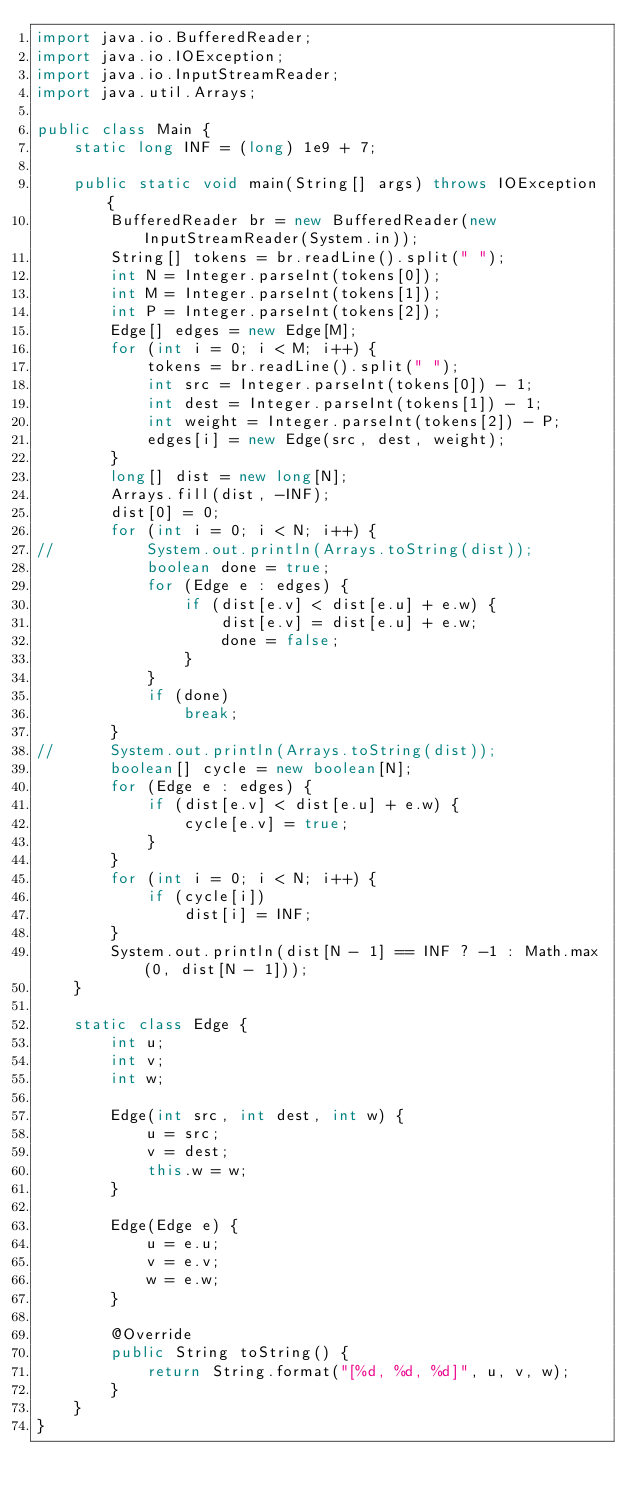<code> <loc_0><loc_0><loc_500><loc_500><_Java_>import java.io.BufferedReader;
import java.io.IOException;
import java.io.InputStreamReader;
import java.util.Arrays;

public class Main {
	static long INF = (long) 1e9 + 7;

	public static void main(String[] args) throws IOException {
		BufferedReader br = new BufferedReader(new InputStreamReader(System.in));
		String[] tokens = br.readLine().split(" ");
		int N = Integer.parseInt(tokens[0]);
		int M = Integer.parseInt(tokens[1]);
		int P = Integer.parseInt(tokens[2]);
		Edge[] edges = new Edge[M];
		for (int i = 0; i < M; i++) {
			tokens = br.readLine().split(" ");
			int src = Integer.parseInt(tokens[0]) - 1;
			int dest = Integer.parseInt(tokens[1]) - 1;
			int weight = Integer.parseInt(tokens[2]) - P;
			edges[i] = new Edge(src, dest, weight);
		}
		long[] dist = new long[N];
		Arrays.fill(dist, -INF);
		dist[0] = 0;
		for (int i = 0; i < N; i++) {
//			System.out.println(Arrays.toString(dist));
			boolean done = true;
			for (Edge e : edges) {
				if (dist[e.v] < dist[e.u] + e.w) {
					dist[e.v] = dist[e.u] + e.w;
					done = false;
				}
			}
			if (done)
				break;
		}
//		System.out.println(Arrays.toString(dist));
		boolean[] cycle = new boolean[N];
		for (Edge e : edges) {
			if (dist[e.v] < dist[e.u] + e.w) {
				cycle[e.v] = true;
			}
		}
		for (int i = 0; i < N; i++) {
			if (cycle[i])
				dist[i] = INF;
		}
		System.out.println(dist[N - 1] == INF ? -1 : Math.max(0, dist[N - 1]));
	}

	static class Edge {
		int u;
		int v;
		int w;

		Edge(int src, int dest, int w) {
			u = src;
			v = dest;
			this.w = w;
		}

		Edge(Edge e) {
			u = e.u;
			v = e.v;
			w = e.w;
		}

		@Override
		public String toString() {
			return String.format("[%d, %d, %d]", u, v, w);
		}
	}
}</code> 